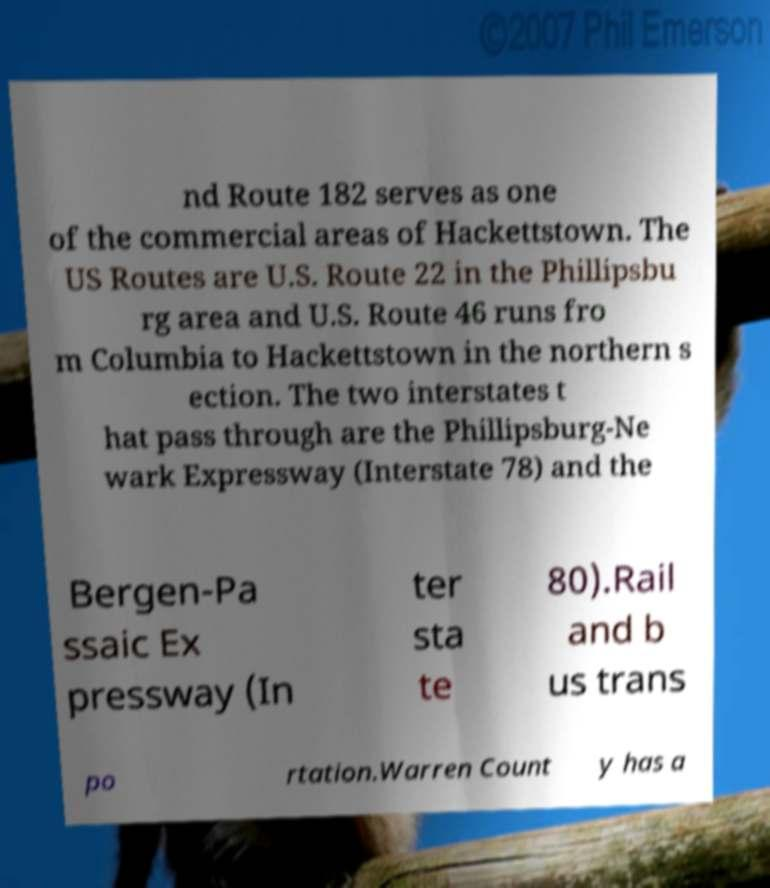What messages or text are displayed in this image? I need them in a readable, typed format. nd Route 182 serves as one of the commercial areas of Hackettstown. The US Routes are U.S. Route 22 in the Phillipsbu rg area and U.S. Route 46 runs fro m Columbia to Hackettstown in the northern s ection. The two interstates t hat pass through are the Phillipsburg-Ne wark Expressway (Interstate 78) and the Bergen-Pa ssaic Ex pressway (In ter sta te 80).Rail and b us trans po rtation.Warren Count y has a 